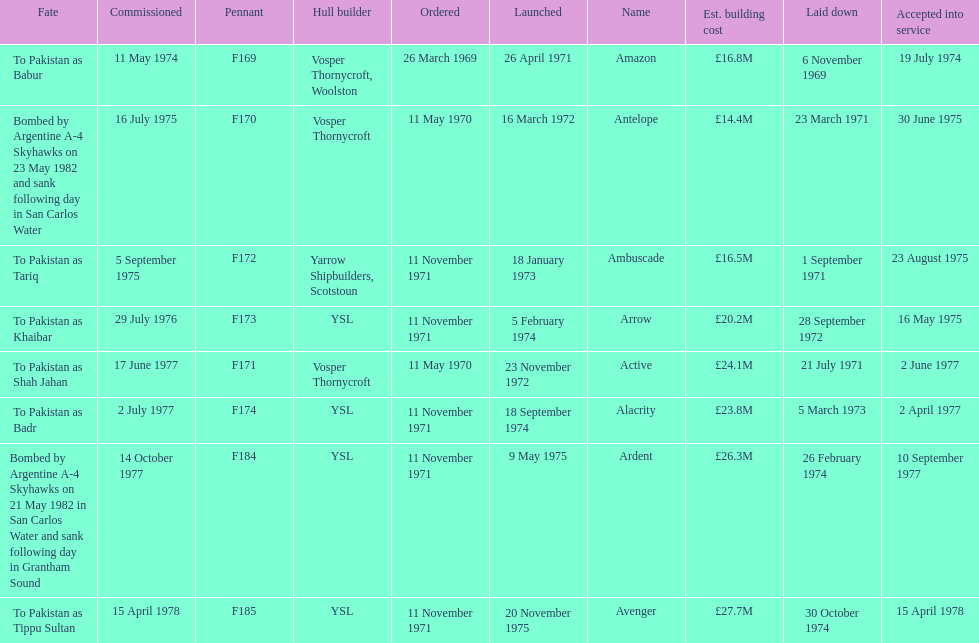I'm looking to parse the entire table for insights. Could you assist me with that? {'header': ['Fate', 'Commissioned', 'Pennant', 'Hull builder', 'Ordered', 'Launched', 'Name', 'Est. building cost', 'Laid down', 'Accepted into service'], 'rows': [['To Pakistan as Babur', '11 May 1974', 'F169', 'Vosper Thornycroft, Woolston', '26 March 1969', '26 April 1971', 'Amazon', '£16.8M', '6 November 1969', '19 July 1974'], ['Bombed by Argentine A-4 Skyhawks on 23 May 1982 and sank following day in San Carlos Water', '16 July 1975', 'F170', 'Vosper Thornycroft', '11 May 1970', '16 March 1972', 'Antelope', '£14.4M', '23 March 1971', '30 June 1975'], ['To Pakistan as Tariq', '5 September 1975', 'F172', 'Yarrow Shipbuilders, Scotstoun', '11 November 1971', '18 January 1973', 'Ambuscade', '£16.5M', '1 September 1971', '23 August 1975'], ['To Pakistan as Khaibar', '29 July 1976', 'F173', 'YSL', '11 November 1971', '5 February 1974', 'Arrow', '£20.2M', '28 September 1972', '16 May 1975'], ['To Pakistan as Shah Jahan', '17 June 1977', 'F171', 'Vosper Thornycroft', '11 May 1970', '23 November 1972', 'Active', '£24.1M', '21 July 1971', '2 June 1977'], ['To Pakistan as Badr', '2 July 1977', 'F174', 'YSL', '11 November 1971', '18 September 1974', 'Alacrity', '£23.8M', '5 March 1973', '2 April 1977'], ['Bombed by Argentine A-4 Skyhawks on 21 May 1982 in San Carlos Water and sank following day in Grantham Sound', '14 October 1977', 'F184', 'YSL', '11 November 1971', '9 May 1975', 'Ardent', '£26.3M', '26 February 1974', '10 September 1977'], ['To Pakistan as Tippu Sultan', '15 April 1978', 'F185', 'YSL', '11 November 1971', '20 November 1975', 'Avenger', '£27.7M', '30 October 1974', '15 April 1978']]} The arrow was ordered on november 11, 1971. what was the previous ship? Ambuscade. 